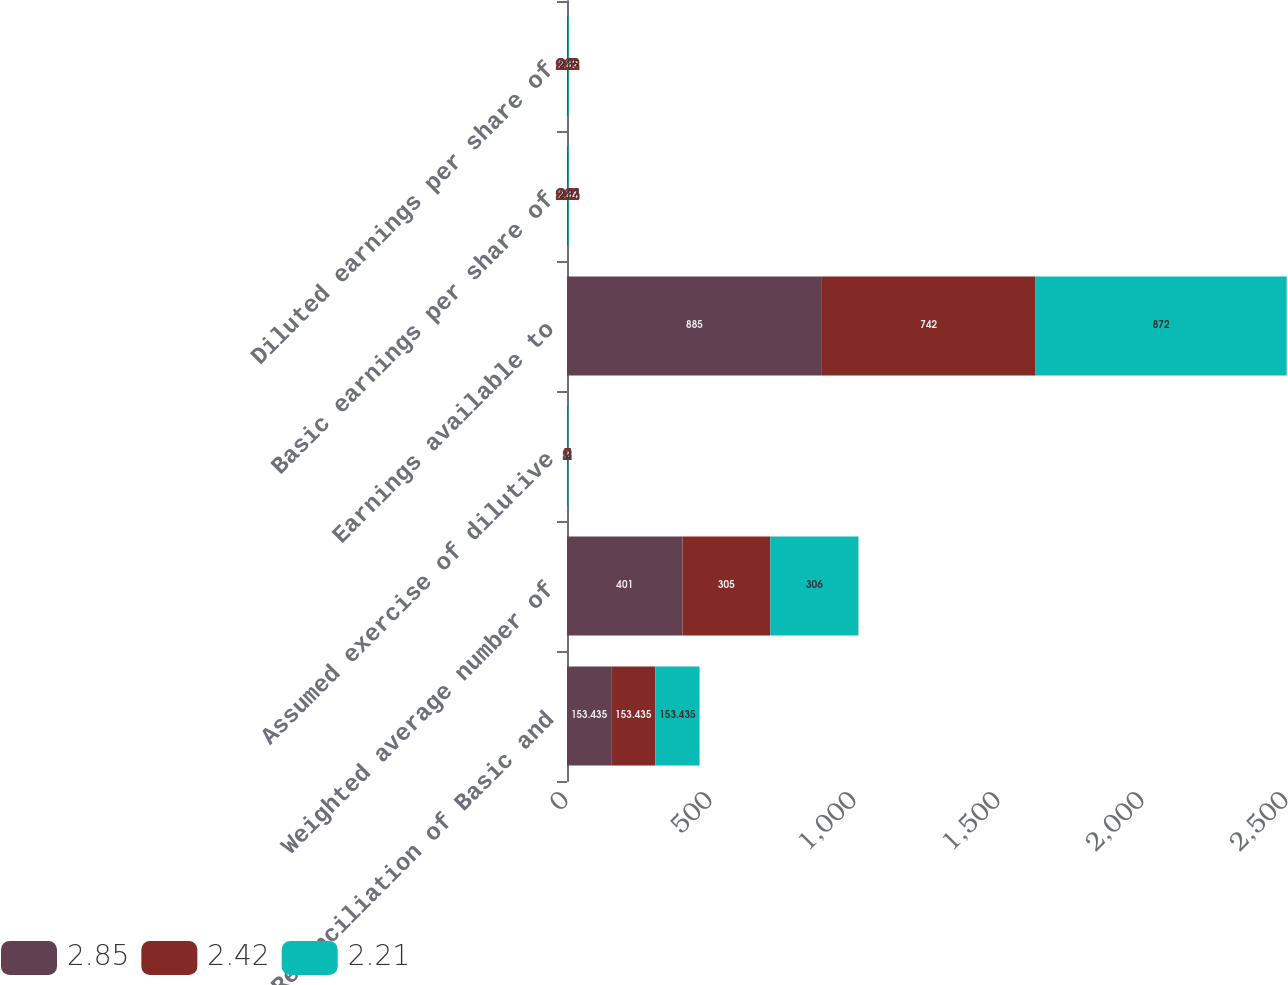<chart> <loc_0><loc_0><loc_500><loc_500><stacked_bar_chart><ecel><fcel>Reconciliation of Basic and<fcel>Weighted average number of<fcel>Assumed exercise of dilutive<fcel>Earnings available to<fcel>Basic earnings per share of<fcel>Diluted earnings per share of<nl><fcel>2.85<fcel>153.435<fcel>401<fcel>2<fcel>885<fcel>2.22<fcel>2.21<nl><fcel>2.42<fcel>153.435<fcel>305<fcel>1<fcel>742<fcel>2.44<fcel>2.42<nl><fcel>2.21<fcel>153.435<fcel>306<fcel>2<fcel>872<fcel>2.87<fcel>2.85<nl></chart> 